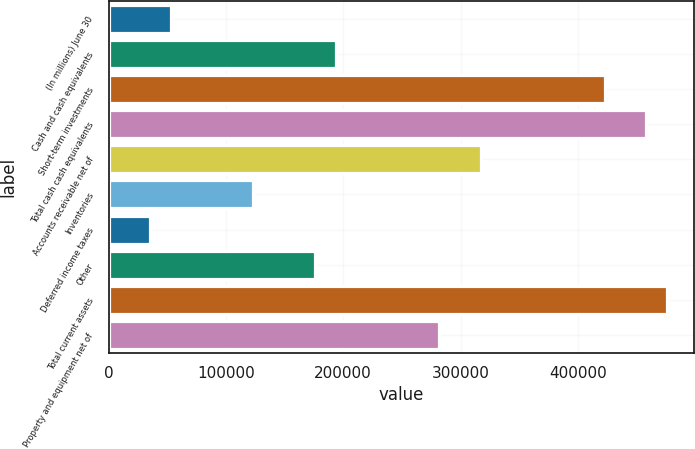<chart> <loc_0><loc_0><loc_500><loc_500><bar_chart><fcel>(In millions) June 30<fcel>Cash and cash equivalents<fcel>Short-term investments<fcel>Total cash cash equivalents<fcel>Accounts receivable net of<fcel>Inventories<fcel>Deferred income taxes<fcel>Other<fcel>Total current assets<fcel>Property and equipment net of<nl><fcel>52931.3<fcel>193836<fcel>422806<fcel>458033<fcel>317128<fcel>123384<fcel>35318.2<fcel>176223<fcel>475646<fcel>281902<nl></chart> 